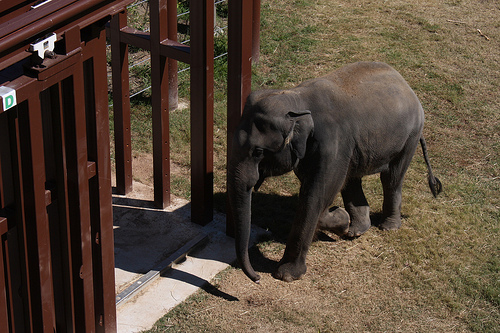<image>
Is there a elephant baby on the ground? Yes. Looking at the image, I can see the elephant baby is positioned on top of the ground, with the ground providing support. Where is the elephant in relation to the floor? Is it on the floor? Yes. Looking at the image, I can see the elephant is positioned on top of the floor, with the floor providing support. 